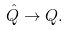Convert formula to latex. <formula><loc_0><loc_0><loc_500><loc_500>\hat { Q } \rightarrow Q .</formula> 